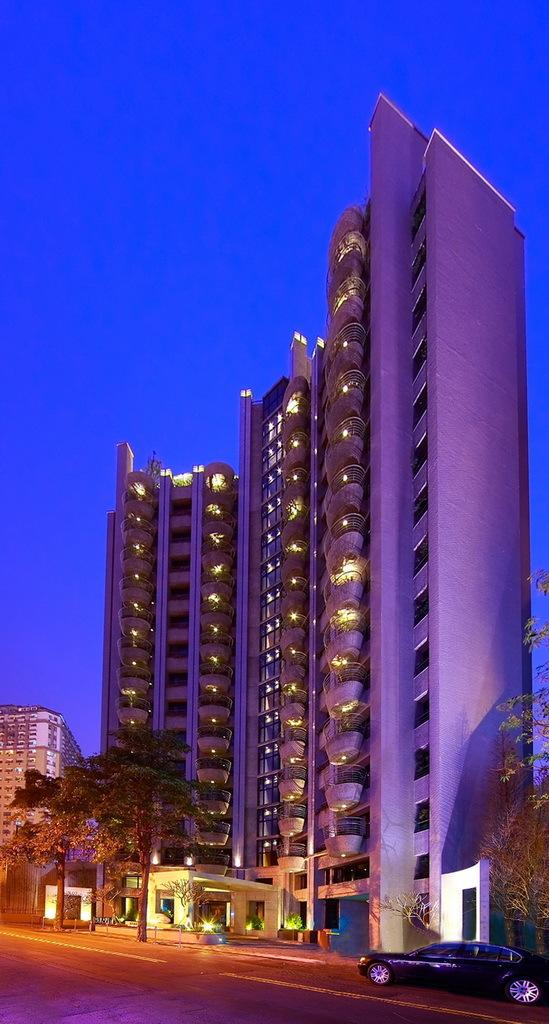What type of structures can be seen in the image? There are buildings in the image. What other natural elements are present in the image? There are trees in the image. What mode of transportation is visible on the road in the image? There is a vehicle on the road in the image. What can be seen in the background of the image? The sky is visible in the background of the image. What nation is the minister from in the image? There is no nation or minister present in the image. 